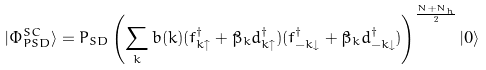<formula> <loc_0><loc_0><loc_500><loc_500>| \Phi _ { P S D } ^ { S C } \rangle = P _ { S D } \left ( \sum _ { k } b ( k ) ( f _ { k \uparrow } ^ { \dagger } + \tilde { \beta } _ { k } d _ { k \uparrow } ^ { \dagger } ) ( f _ { - k \downarrow } ^ { \dagger } + \tilde { \beta } _ { k } d _ { - k \downarrow } ^ { \dagger } ) \right ) ^ { \frac { N + N _ { h } } { 2 } } | 0 \rangle</formula> 